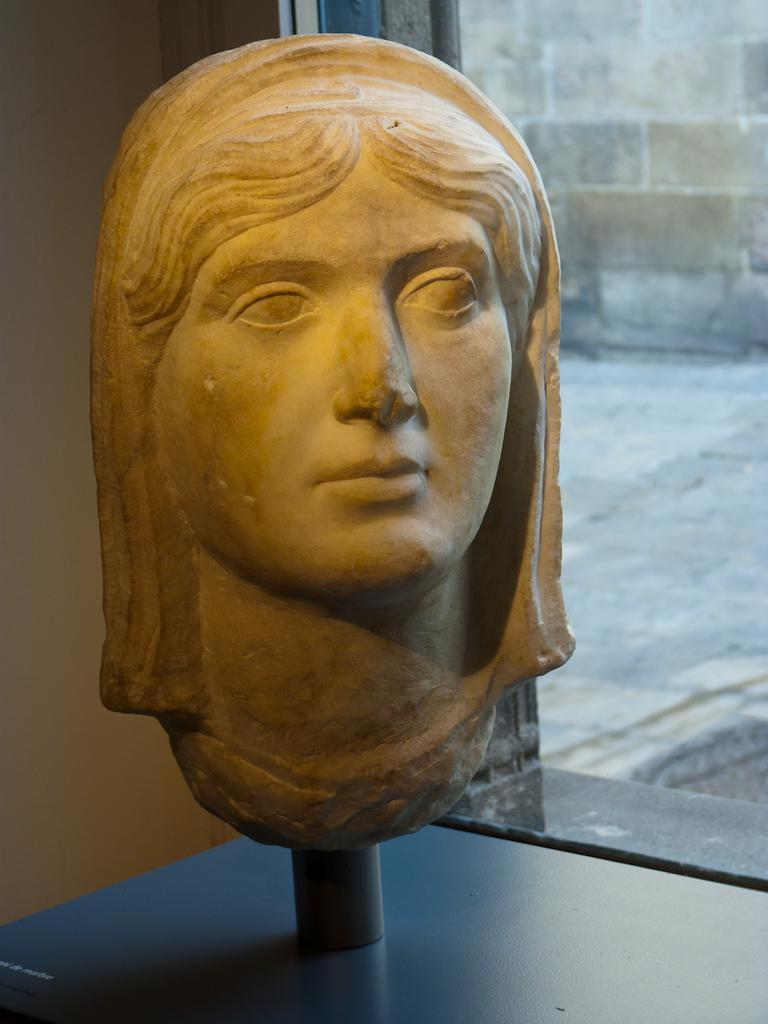What is the main subject in the image? There is a sculpture in the image. What is the rod used for in the image? The rod is a part of the sculpture. What is the sculpture placed on in the image? There is a surface in the image where the sculpture is placed. What can be seen in the background of the image? There is a wall in the background of the image. What is on the right side of the image? There is a walkway and a wall on the right side of the image. How many cherries are hanging from the bat in the image? There is no bat or cherries present in the image. 